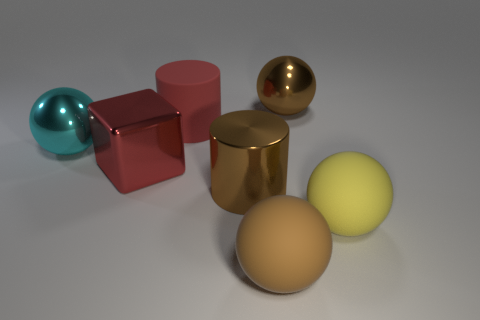Are there any repeating shapes in this image? Yes, there are repeating shapes in the image. The spheres repeat with one large and one small yellow sphere, and another sphere that is shiny and blue. The cylinder shape is also repeated with one being a golden cylinder and the other a red cube which is technically a stretched version of a square, a cousin to the cylinder in geometric terms. 